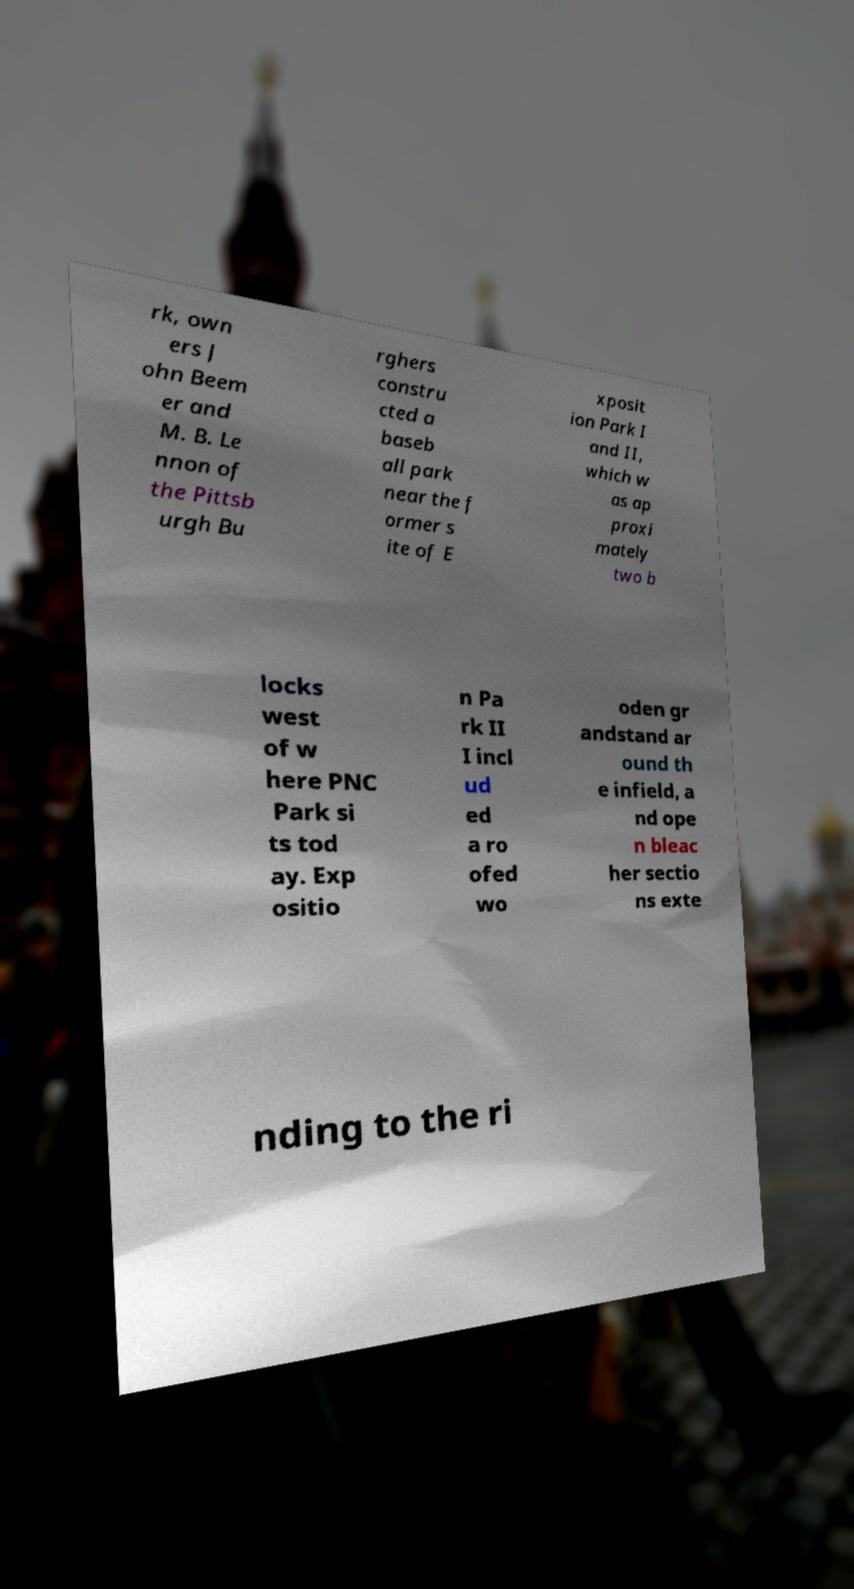Please read and relay the text visible in this image. What does it say? rk, own ers J ohn Beem er and M. B. Le nnon of the Pittsb urgh Bu rghers constru cted a baseb all park near the f ormer s ite of E xposit ion Park I and II, which w as ap proxi mately two b locks west of w here PNC Park si ts tod ay. Exp ositio n Pa rk II I incl ud ed a ro ofed wo oden gr andstand ar ound th e infield, a nd ope n bleac her sectio ns exte nding to the ri 